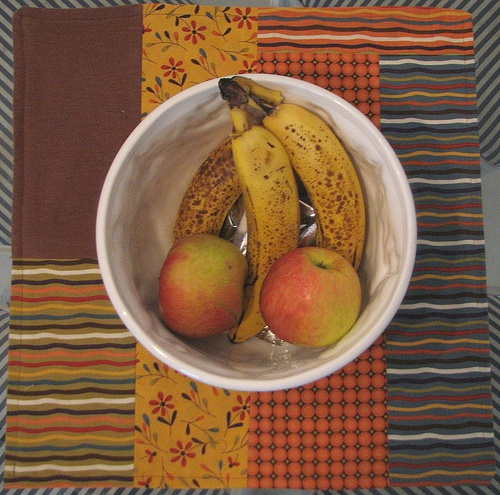Describe the objects in this image and their specific colors. I can see bowl in gray, brown, tan, and maroon tones, apple in gray, brown, maroon, and olive tones, and apple in gray, red, olive, and brown tones in this image. 